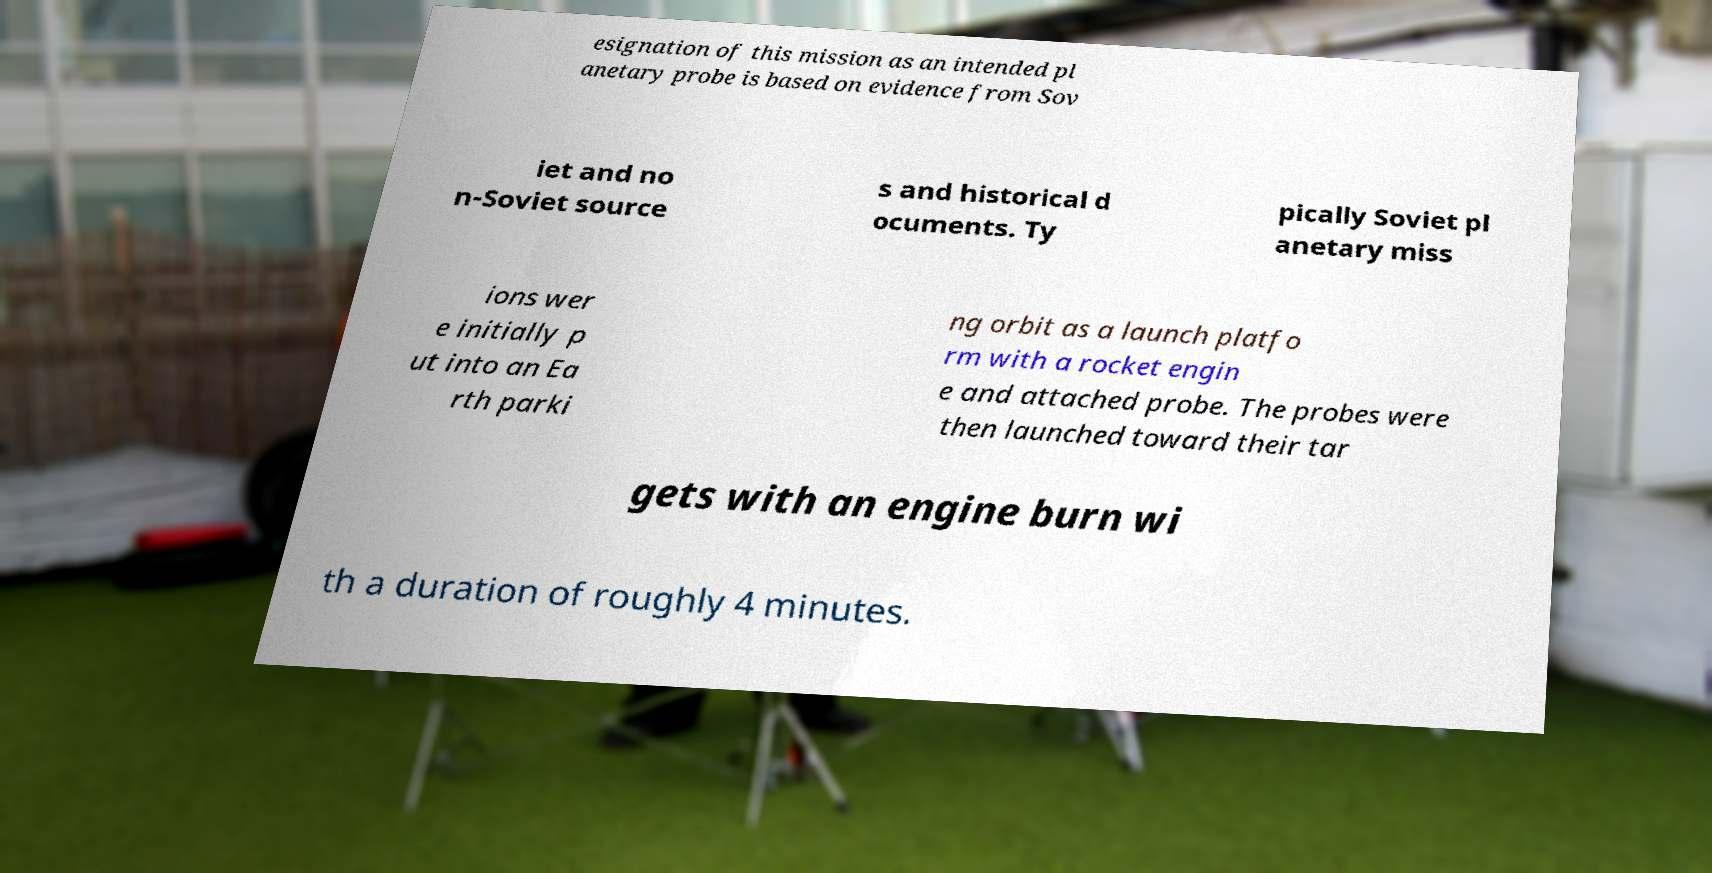Please read and relay the text visible in this image. What does it say? esignation of this mission as an intended pl anetary probe is based on evidence from Sov iet and no n-Soviet source s and historical d ocuments. Ty pically Soviet pl anetary miss ions wer e initially p ut into an Ea rth parki ng orbit as a launch platfo rm with a rocket engin e and attached probe. The probes were then launched toward their tar gets with an engine burn wi th a duration of roughly 4 minutes. 